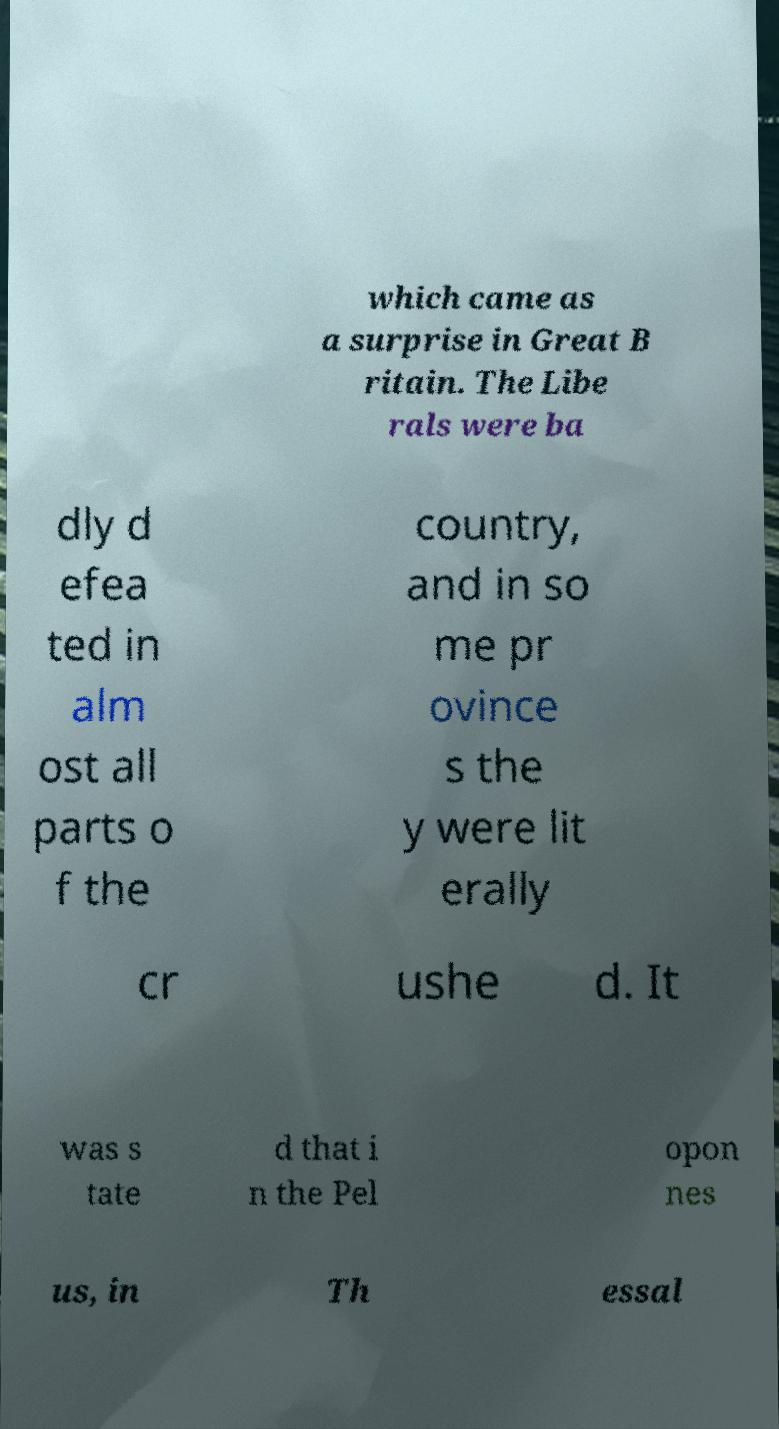Please identify and transcribe the text found in this image. which came as a surprise in Great B ritain. The Libe rals were ba dly d efea ted in alm ost all parts o f the country, and in so me pr ovince s the y were lit erally cr ushe d. It was s tate d that i n the Pel opon nes us, in Th essal 